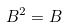<formula> <loc_0><loc_0><loc_500><loc_500>B ^ { 2 } = B</formula> 